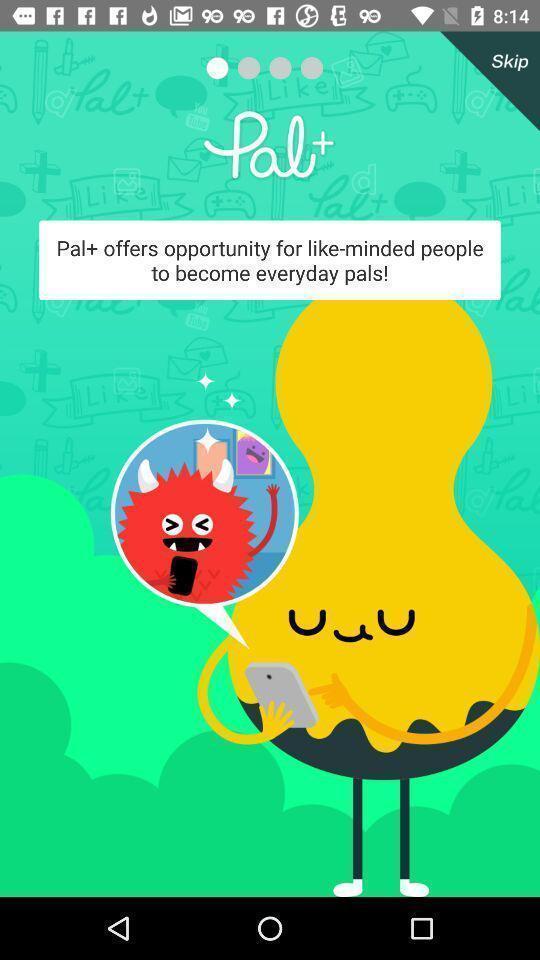Describe the key features of this screenshot. Welcome page for the social media app. 